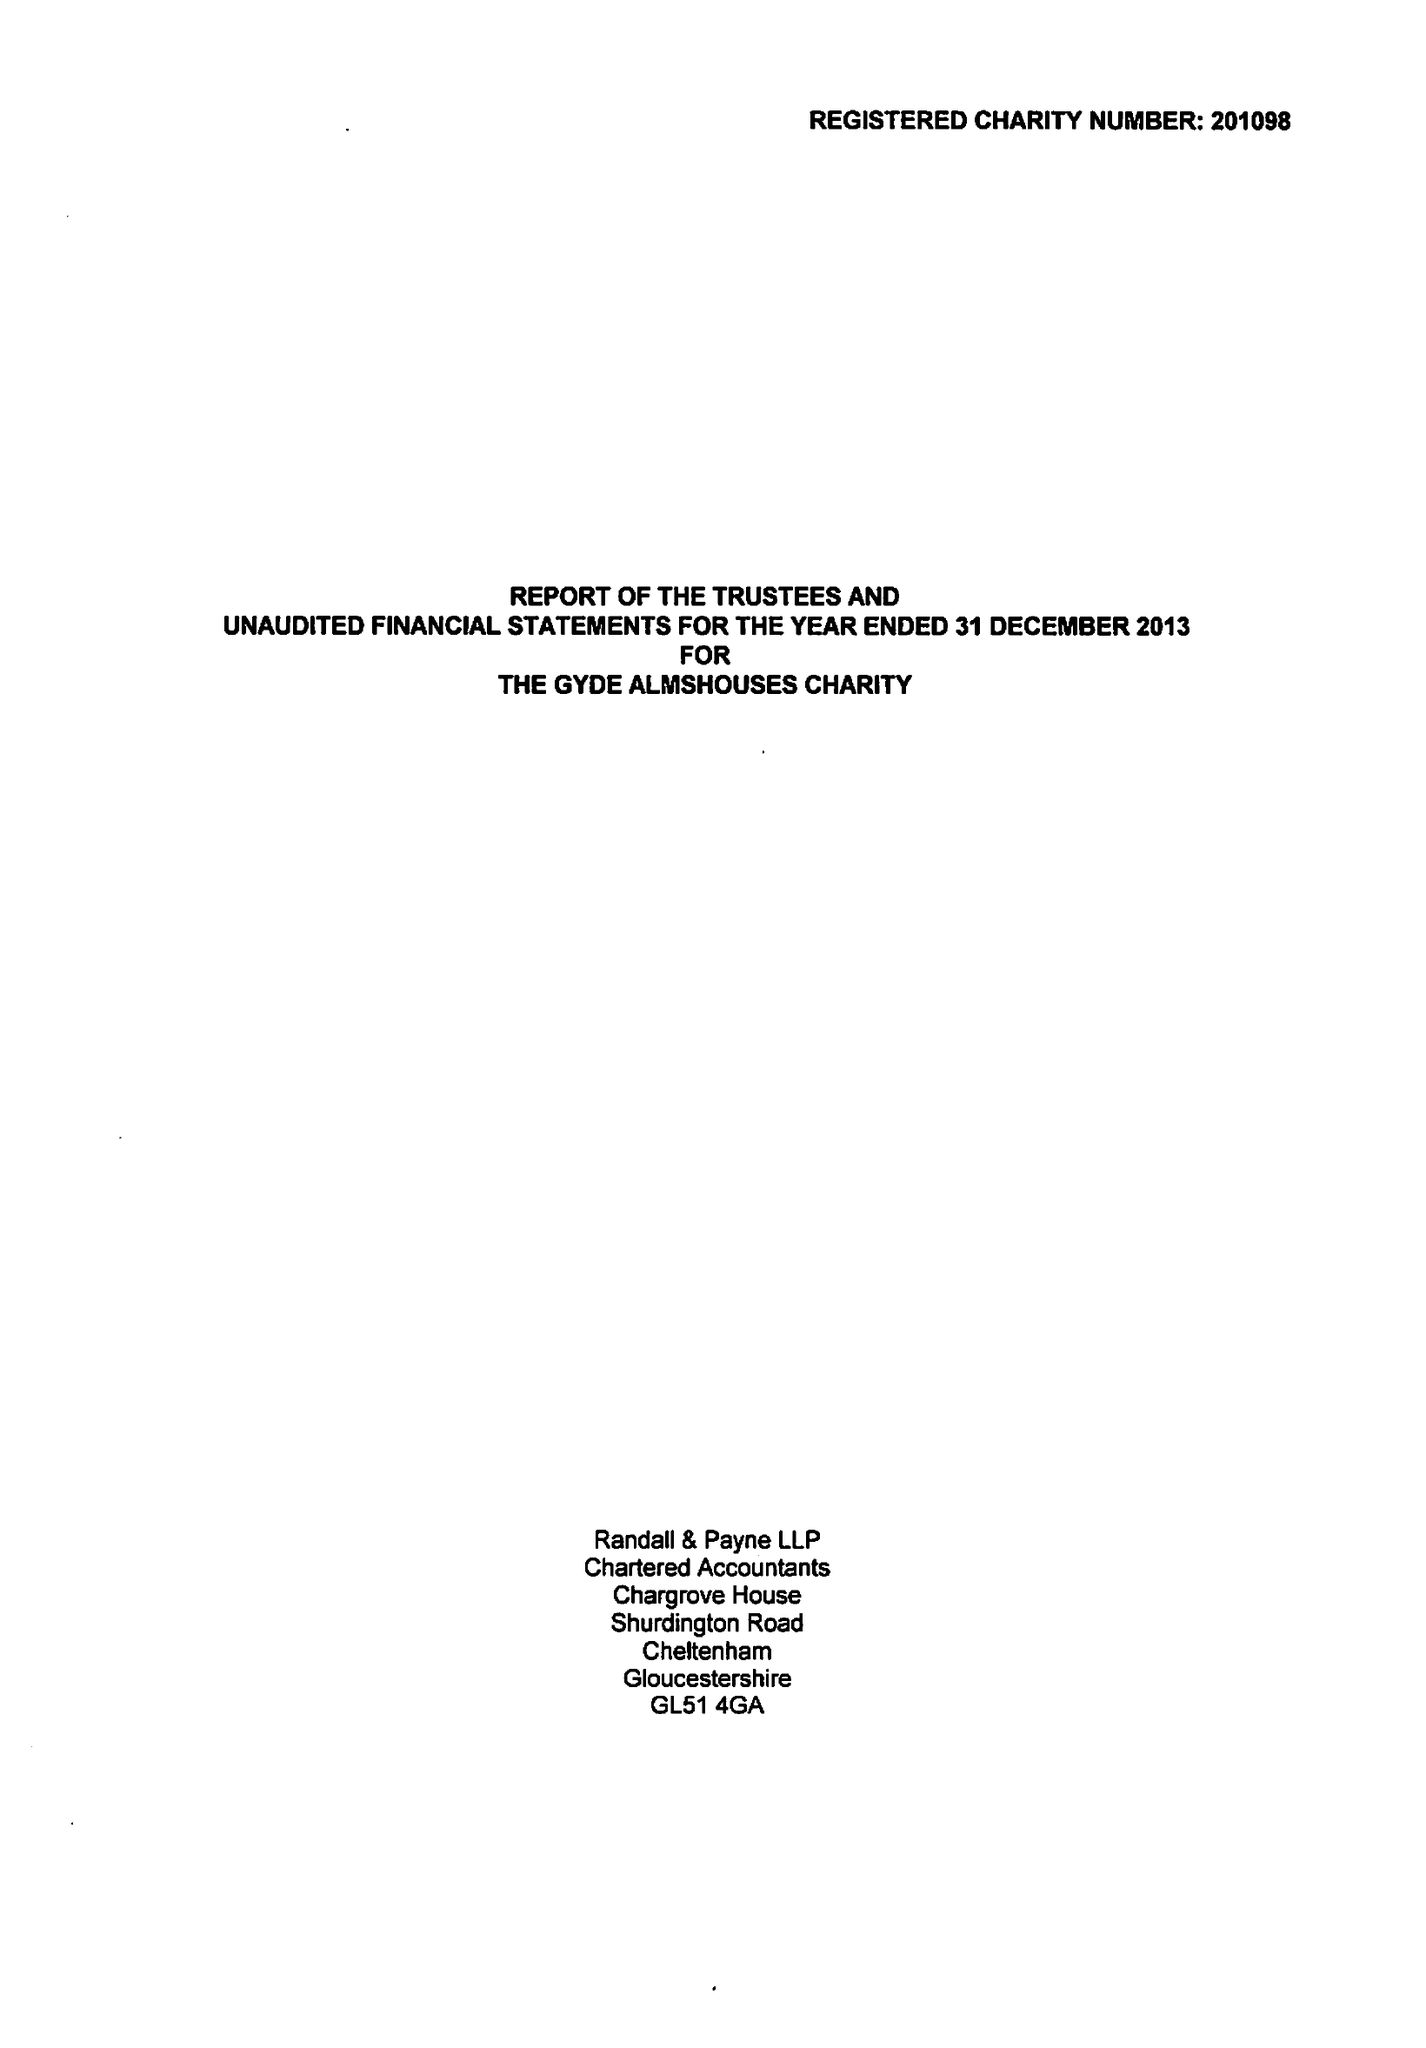What is the value for the address__postcode?
Answer the question using a single word or phrase. GL11 5TH 